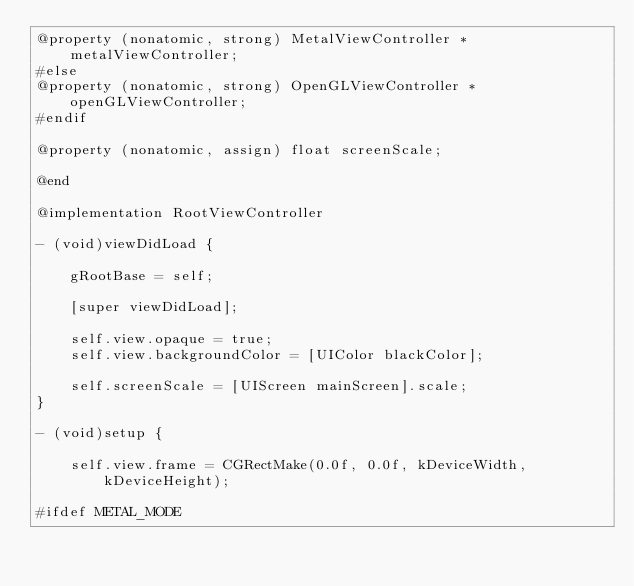<code> <loc_0><loc_0><loc_500><loc_500><_ObjectiveC_>@property (nonatomic, strong) MetalViewController *metalViewController;
#else
@property (nonatomic, strong) OpenGLViewController *openGLViewController;
#endif

@property (nonatomic, assign) float screenScale;

@end

@implementation RootViewController

- (void)viewDidLoad {
    
    gRootBase = self;
    
    [super viewDidLoad];
    
    self.view.opaque = true;
    self.view.backgroundColor = [UIColor blackColor];
    
    self.screenScale = [UIScreen mainScreen].scale;
}

- (void)setup {
    
    self.view.frame = CGRectMake(0.0f, 0.0f, kDeviceWidth, kDeviceHeight);
    
#ifdef METAL_MODE</code> 